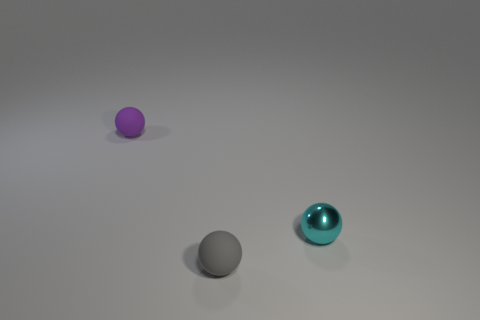Add 1 green metallic blocks. How many objects exist? 4 Add 2 big green metal cylinders. How many big green metal cylinders exist? 2 Subtract 1 purple spheres. How many objects are left? 2 Subtract all small gray things. Subtract all tiny cyan spheres. How many objects are left? 1 Add 1 tiny purple matte things. How many tiny purple matte things are left? 2 